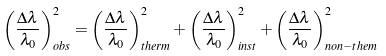<formula> <loc_0><loc_0><loc_500><loc_500>\left ( { \frac { \Delta \lambda } { \lambda _ { 0 } } } \right ) _ { o b s } ^ { 2 } = \left ( { \frac { \Delta \lambda } { \lambda _ { 0 } } } \right ) _ { t h e r m } ^ { 2 } + \left ( { \frac { \Delta \lambda } { \lambda _ { 0 } } } \right ) _ { i n s t } ^ { 2 } + \left ( { \frac { \Delta \lambda } { \lambda _ { 0 } } } \right ) _ { n o n - t h e m } ^ { 2 }</formula> 